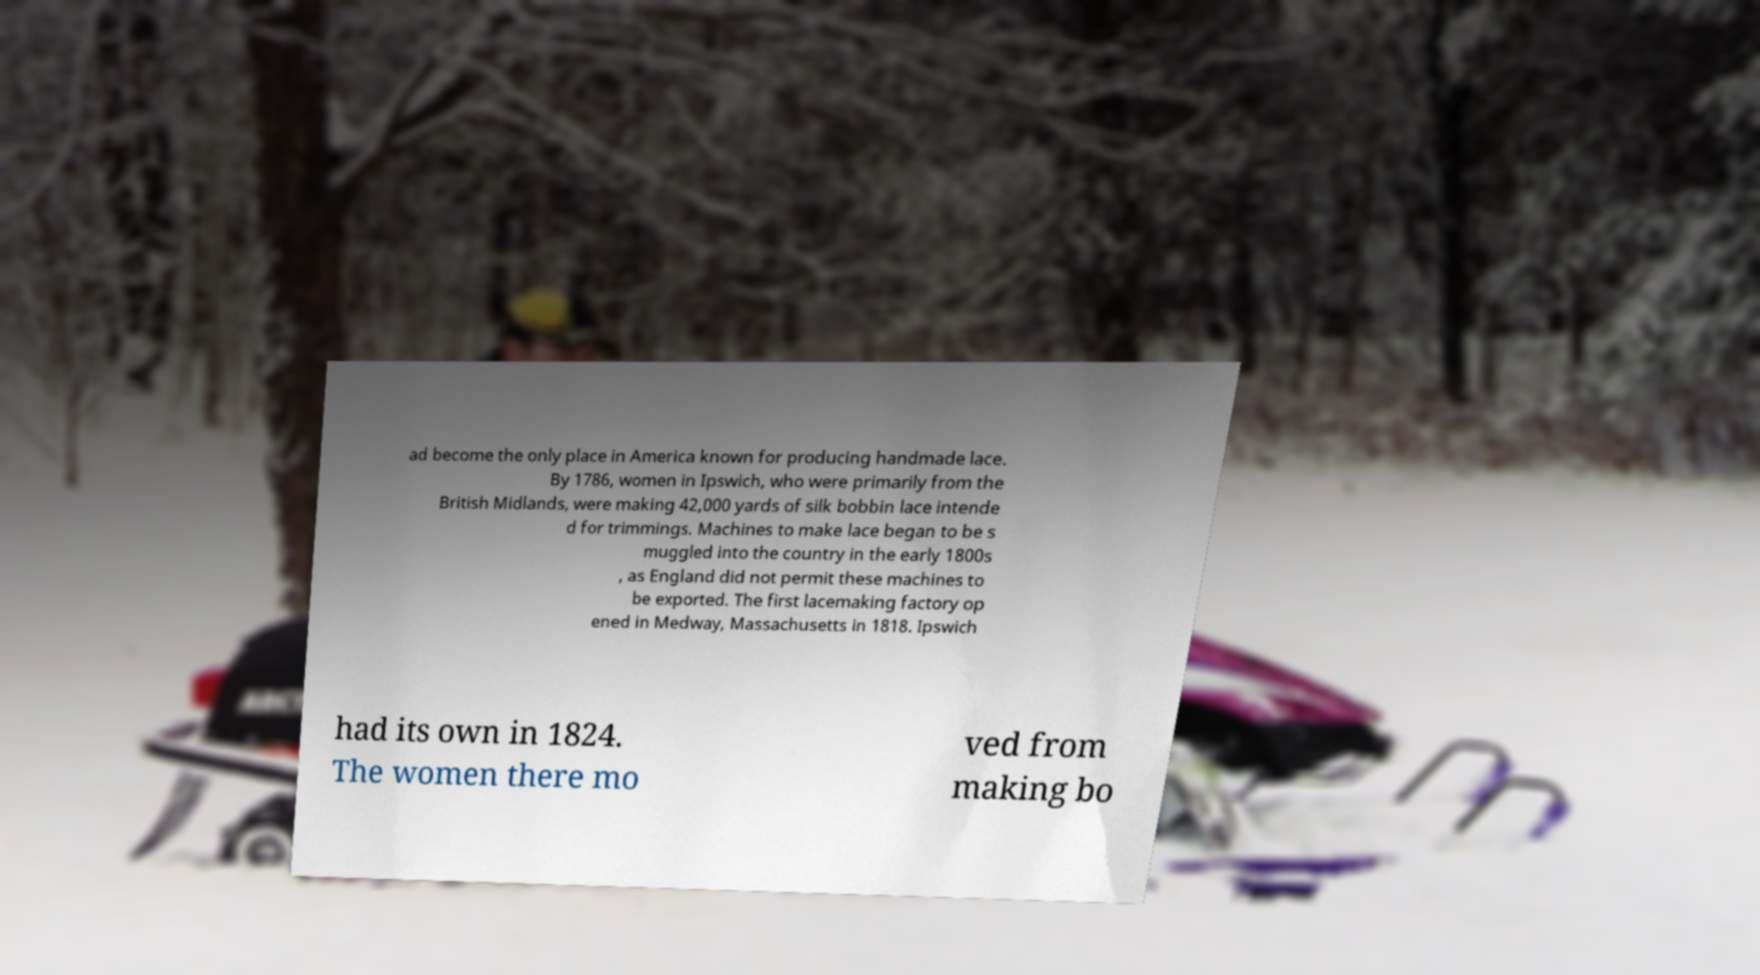For documentation purposes, I need the text within this image transcribed. Could you provide that? ad become the only place in America known for producing handmade lace. By 1786, women in Ipswich, who were primarily from the British Midlands, were making 42,000 yards of silk bobbin lace intende d for trimmings. Machines to make lace began to be s muggled into the country in the early 1800s , as England did not permit these machines to be exported. The first lacemaking factory op ened in Medway, Massachusetts in 1818. Ipswich had its own in 1824. The women there mo ved from making bo 